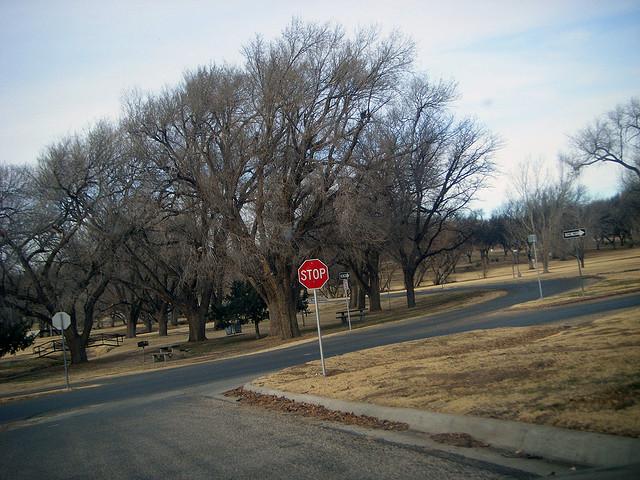Are they playing in the street?
Be succinct. No. How many roads are there?
Keep it brief. 3. Are the trees green?
Concise answer only. No. Is this a safety zone?
Short answer required. No. Does the grass look healthy?
Answer briefly. No. What color is the picture?
Quick response, please. Browns and blue with red. Would you stop at this corner?
Concise answer only. Yes. Is this a warm or a cold day?
Quick response, please. Cold. Is this a busy road?
Give a very brief answer. No. 